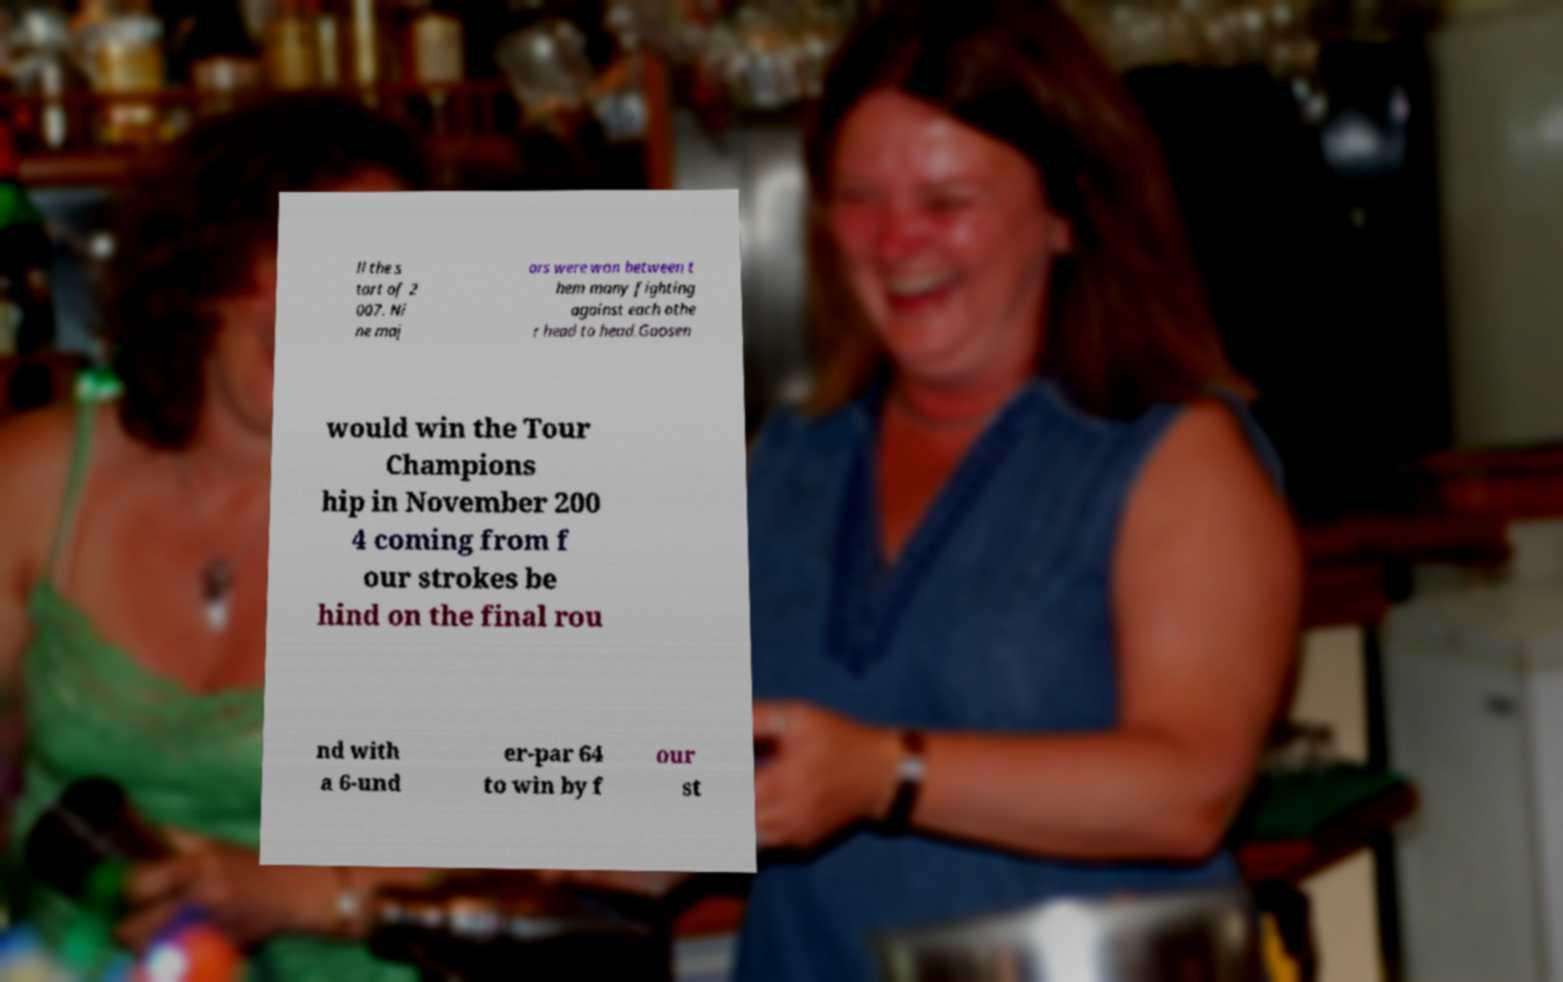Can you read and provide the text displayed in the image?This photo seems to have some interesting text. Can you extract and type it out for me? ll the s tart of 2 007. Ni ne maj ors were won between t hem many fighting against each othe r head to head.Goosen would win the Tour Champions hip in November 200 4 coming from f our strokes be hind on the final rou nd with a 6-und er-par 64 to win by f our st 